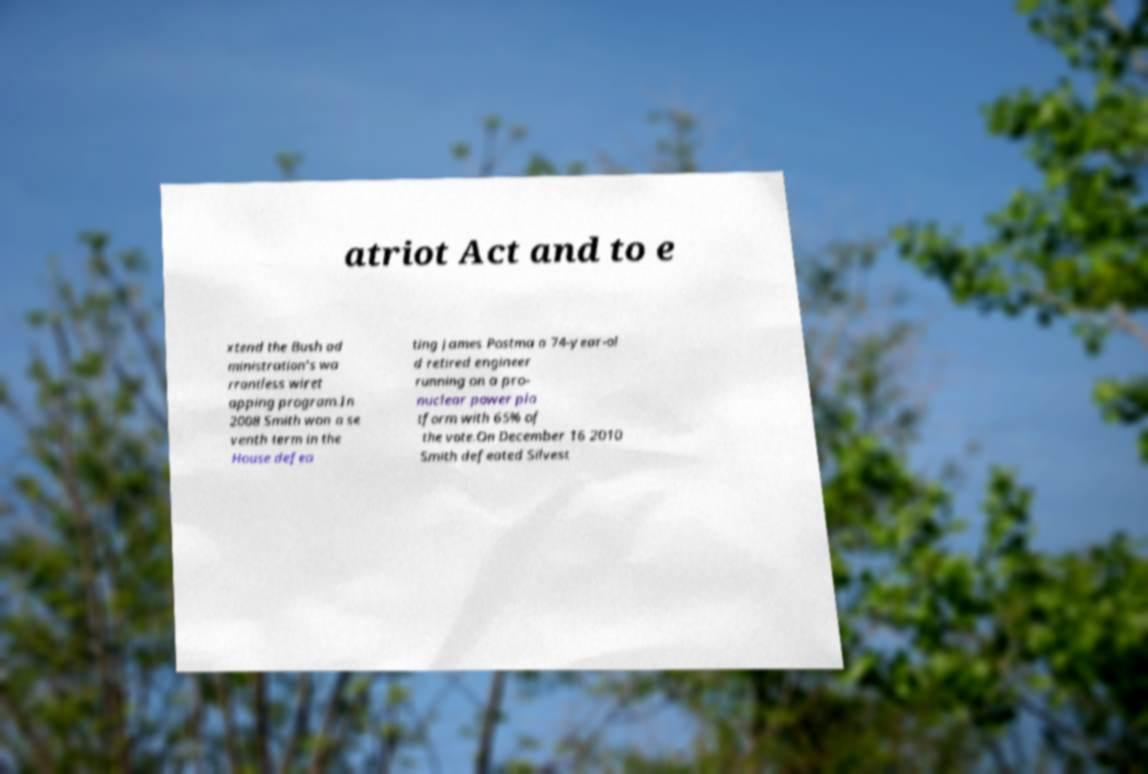Can you accurately transcribe the text from the provided image for me? atriot Act and to e xtend the Bush ad ministration's wa rrantless wiret apping program.In 2008 Smith won a se venth term in the House defea ting James Postma a 74-year-ol d retired engineer running on a pro- nuclear power pla tform with 65% of the vote.On December 16 2010 Smith defeated Silvest 